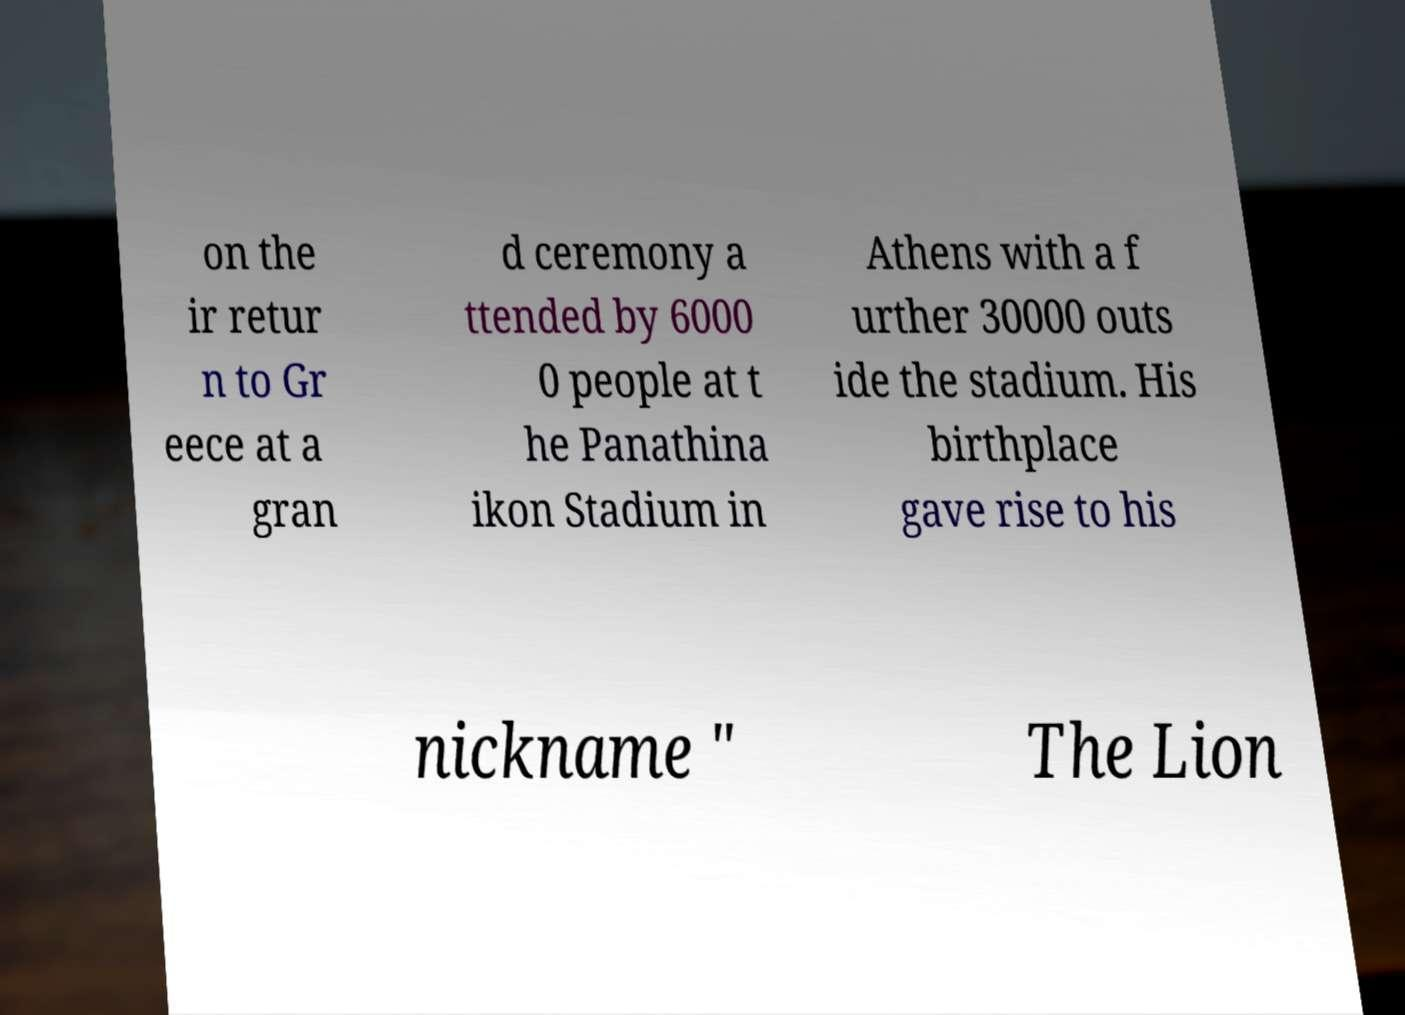Please read and relay the text visible in this image. What does it say? on the ir retur n to Gr eece at a gran d ceremony a ttended by 6000 0 people at t he Panathina ikon Stadium in Athens with a f urther 30000 outs ide the stadium. His birthplace gave rise to his nickname " The Lion 